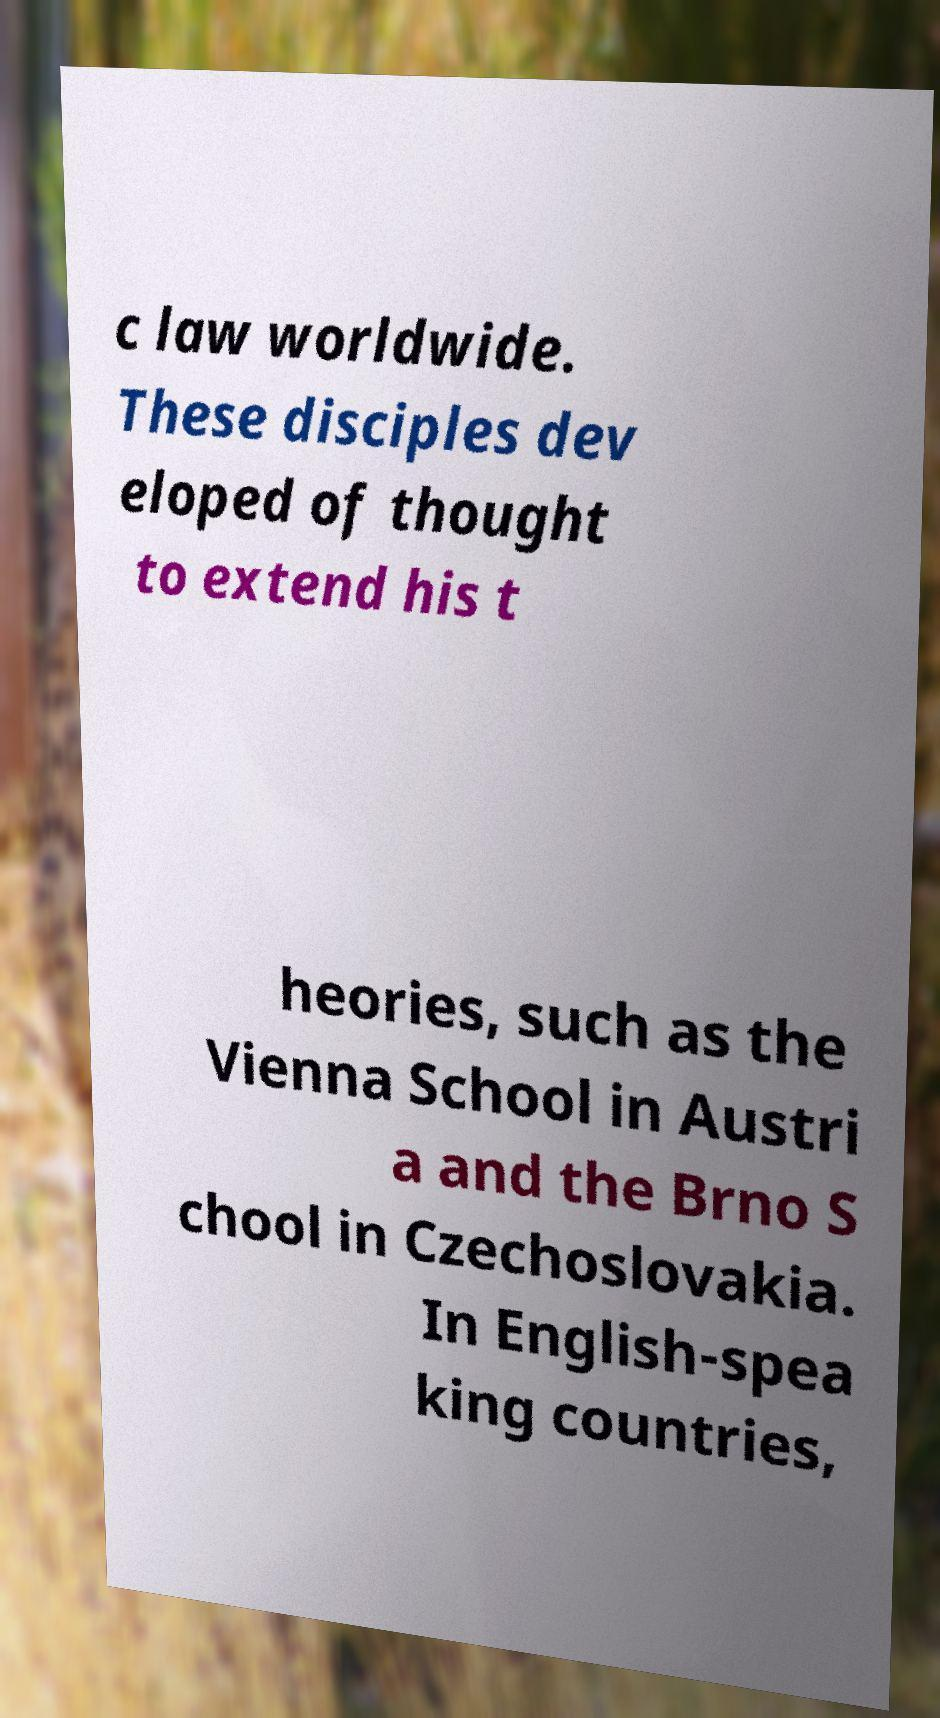There's text embedded in this image that I need extracted. Can you transcribe it verbatim? c law worldwide. These disciples dev eloped of thought to extend his t heories, such as the Vienna School in Austri a and the Brno S chool in Czechoslovakia. In English-spea king countries, 